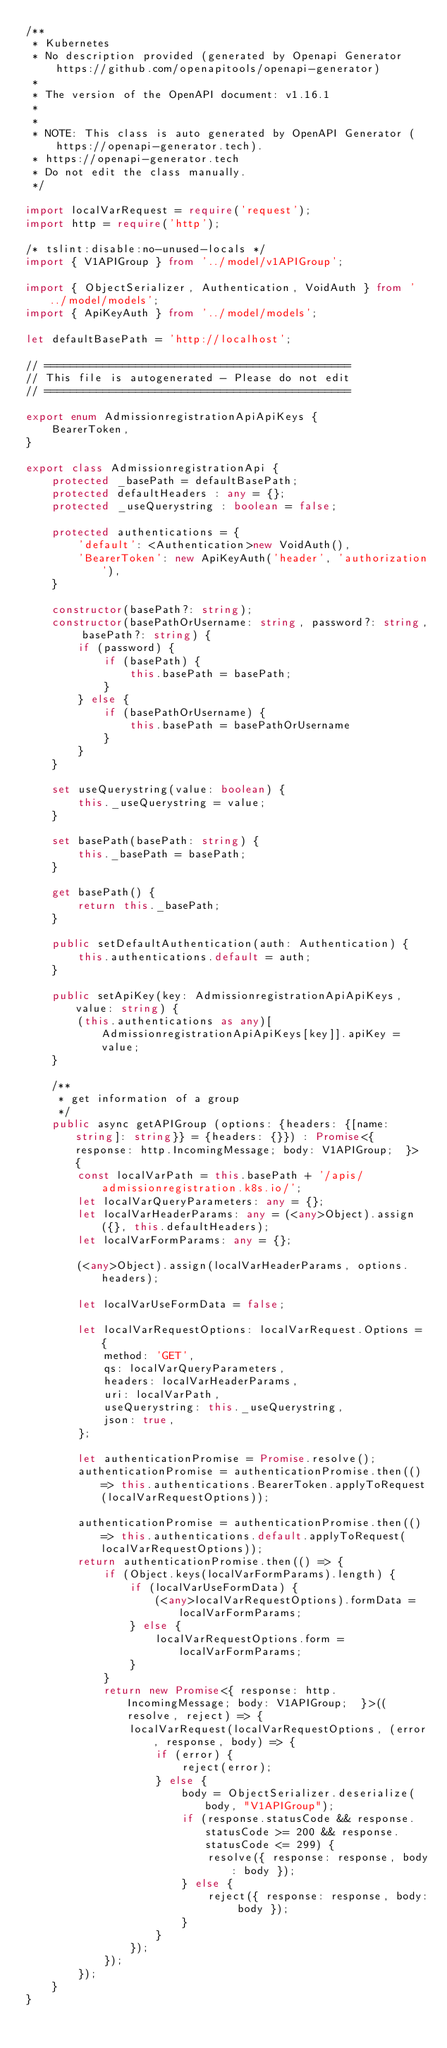Convert code to text. <code><loc_0><loc_0><loc_500><loc_500><_TypeScript_>/**
 * Kubernetes
 * No description provided (generated by Openapi Generator https://github.com/openapitools/openapi-generator)
 *
 * The version of the OpenAPI document: v1.16.1
 * 
 *
 * NOTE: This class is auto generated by OpenAPI Generator (https://openapi-generator.tech).
 * https://openapi-generator.tech
 * Do not edit the class manually.
 */

import localVarRequest = require('request');
import http = require('http');

/* tslint:disable:no-unused-locals */
import { V1APIGroup } from '../model/v1APIGroup';

import { ObjectSerializer, Authentication, VoidAuth } from '../model/models';
import { ApiKeyAuth } from '../model/models';

let defaultBasePath = 'http://localhost';

// ===============================================
// This file is autogenerated - Please do not edit
// ===============================================

export enum AdmissionregistrationApiApiKeys {
    BearerToken,
}

export class AdmissionregistrationApi {
    protected _basePath = defaultBasePath;
    protected defaultHeaders : any = {};
    protected _useQuerystring : boolean = false;

    protected authentications = {
        'default': <Authentication>new VoidAuth(),
        'BearerToken': new ApiKeyAuth('header', 'authorization'),
    }

    constructor(basePath?: string);
    constructor(basePathOrUsername: string, password?: string, basePath?: string) {
        if (password) {
            if (basePath) {
                this.basePath = basePath;
            }
        } else {
            if (basePathOrUsername) {
                this.basePath = basePathOrUsername
            }
        }
    }

    set useQuerystring(value: boolean) {
        this._useQuerystring = value;
    }

    set basePath(basePath: string) {
        this._basePath = basePath;
    }

    get basePath() {
        return this._basePath;
    }

    public setDefaultAuthentication(auth: Authentication) {
        this.authentications.default = auth;
    }

    public setApiKey(key: AdmissionregistrationApiApiKeys, value: string) {
        (this.authentications as any)[AdmissionregistrationApiApiKeys[key]].apiKey = value;
    }

    /**
     * get information of a group
     */
    public async getAPIGroup (options: {headers: {[name: string]: string}} = {headers: {}}) : Promise<{ response: http.IncomingMessage; body: V1APIGroup;  }> {
        const localVarPath = this.basePath + '/apis/admissionregistration.k8s.io/';
        let localVarQueryParameters: any = {};
        let localVarHeaderParams: any = (<any>Object).assign({}, this.defaultHeaders);
        let localVarFormParams: any = {};

        (<any>Object).assign(localVarHeaderParams, options.headers);

        let localVarUseFormData = false;

        let localVarRequestOptions: localVarRequest.Options = {
            method: 'GET',
            qs: localVarQueryParameters,
            headers: localVarHeaderParams,
            uri: localVarPath,
            useQuerystring: this._useQuerystring,
            json: true,
        };

        let authenticationPromise = Promise.resolve();
        authenticationPromise = authenticationPromise.then(() => this.authentications.BearerToken.applyToRequest(localVarRequestOptions));

        authenticationPromise = authenticationPromise.then(() => this.authentications.default.applyToRequest(localVarRequestOptions));
        return authenticationPromise.then(() => {
            if (Object.keys(localVarFormParams).length) {
                if (localVarUseFormData) {
                    (<any>localVarRequestOptions).formData = localVarFormParams;
                } else {
                    localVarRequestOptions.form = localVarFormParams;
                }
            }
            return new Promise<{ response: http.IncomingMessage; body: V1APIGroup;  }>((resolve, reject) => {
                localVarRequest(localVarRequestOptions, (error, response, body) => {
                    if (error) {
                        reject(error);
                    } else {
                        body = ObjectSerializer.deserialize(body, "V1APIGroup");
                        if (response.statusCode && response.statusCode >= 200 && response.statusCode <= 299) {
                            resolve({ response: response, body: body });
                        } else {
                            reject({ response: response, body: body });
                        }
                    }
                });
            });
        });
    }
}
</code> 